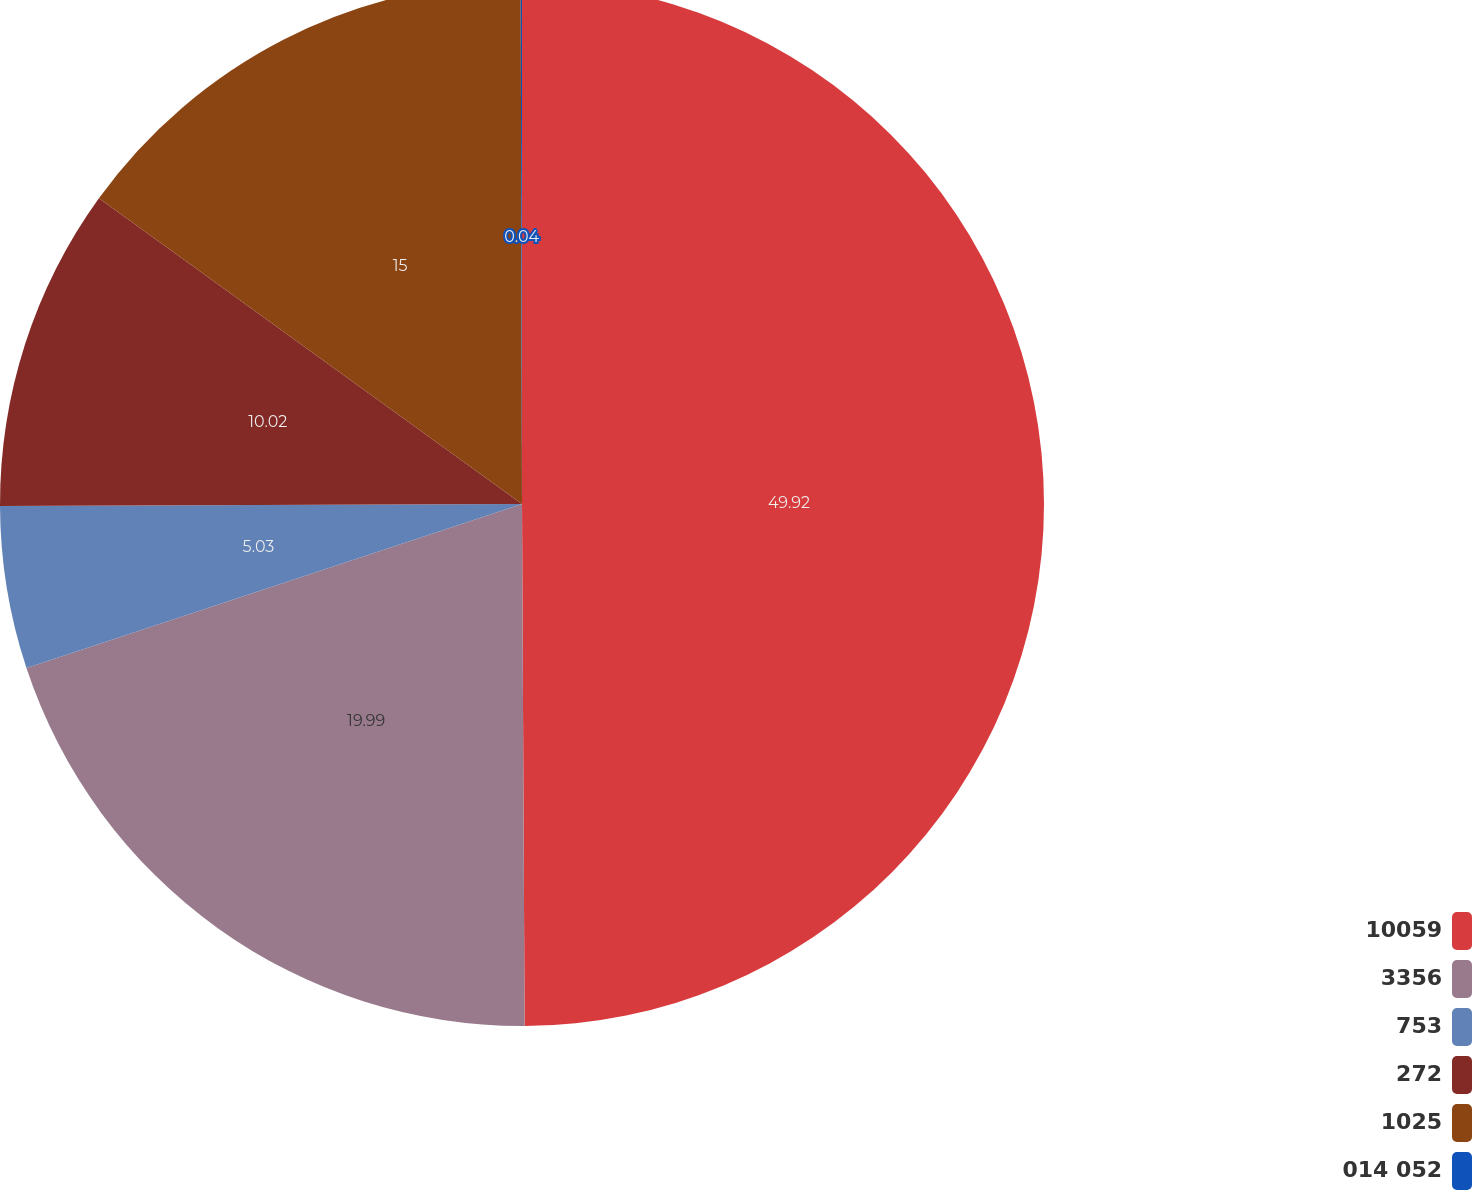Convert chart to OTSL. <chart><loc_0><loc_0><loc_500><loc_500><pie_chart><fcel>10059<fcel>3356<fcel>753<fcel>272<fcel>1025<fcel>014 052<nl><fcel>49.92%<fcel>19.99%<fcel>5.03%<fcel>10.02%<fcel>15.0%<fcel>0.04%<nl></chart> 